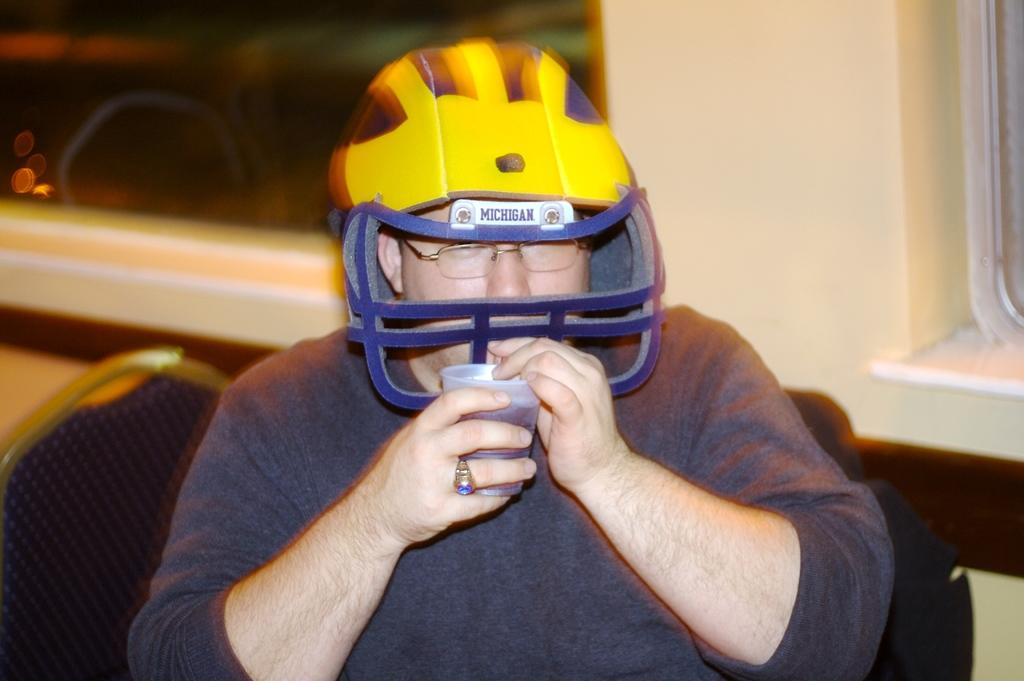What is the main subject of the picture? The main subject of the picture is a man. Can you describe the man's attire in the picture? The man is wearing spectacles, a helmet, a t-shirt, and a finger ring. What is the man holding in the picture? The man is holding a water glass in the picture. What is the man's posture in the picture? The man is sitting on a chair in the picture. What can be seen in the background of the picture? There are windows visible in the background. How many legs does the man have in the picture? The man has two legs, but this question is irrelevant to the image as it focuses on a physical attribute that is not visible or relevant to the content of the image. 